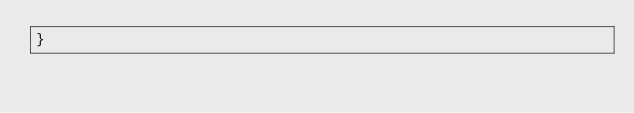<code> <loc_0><loc_0><loc_500><loc_500><_CSS_>}
</code> 